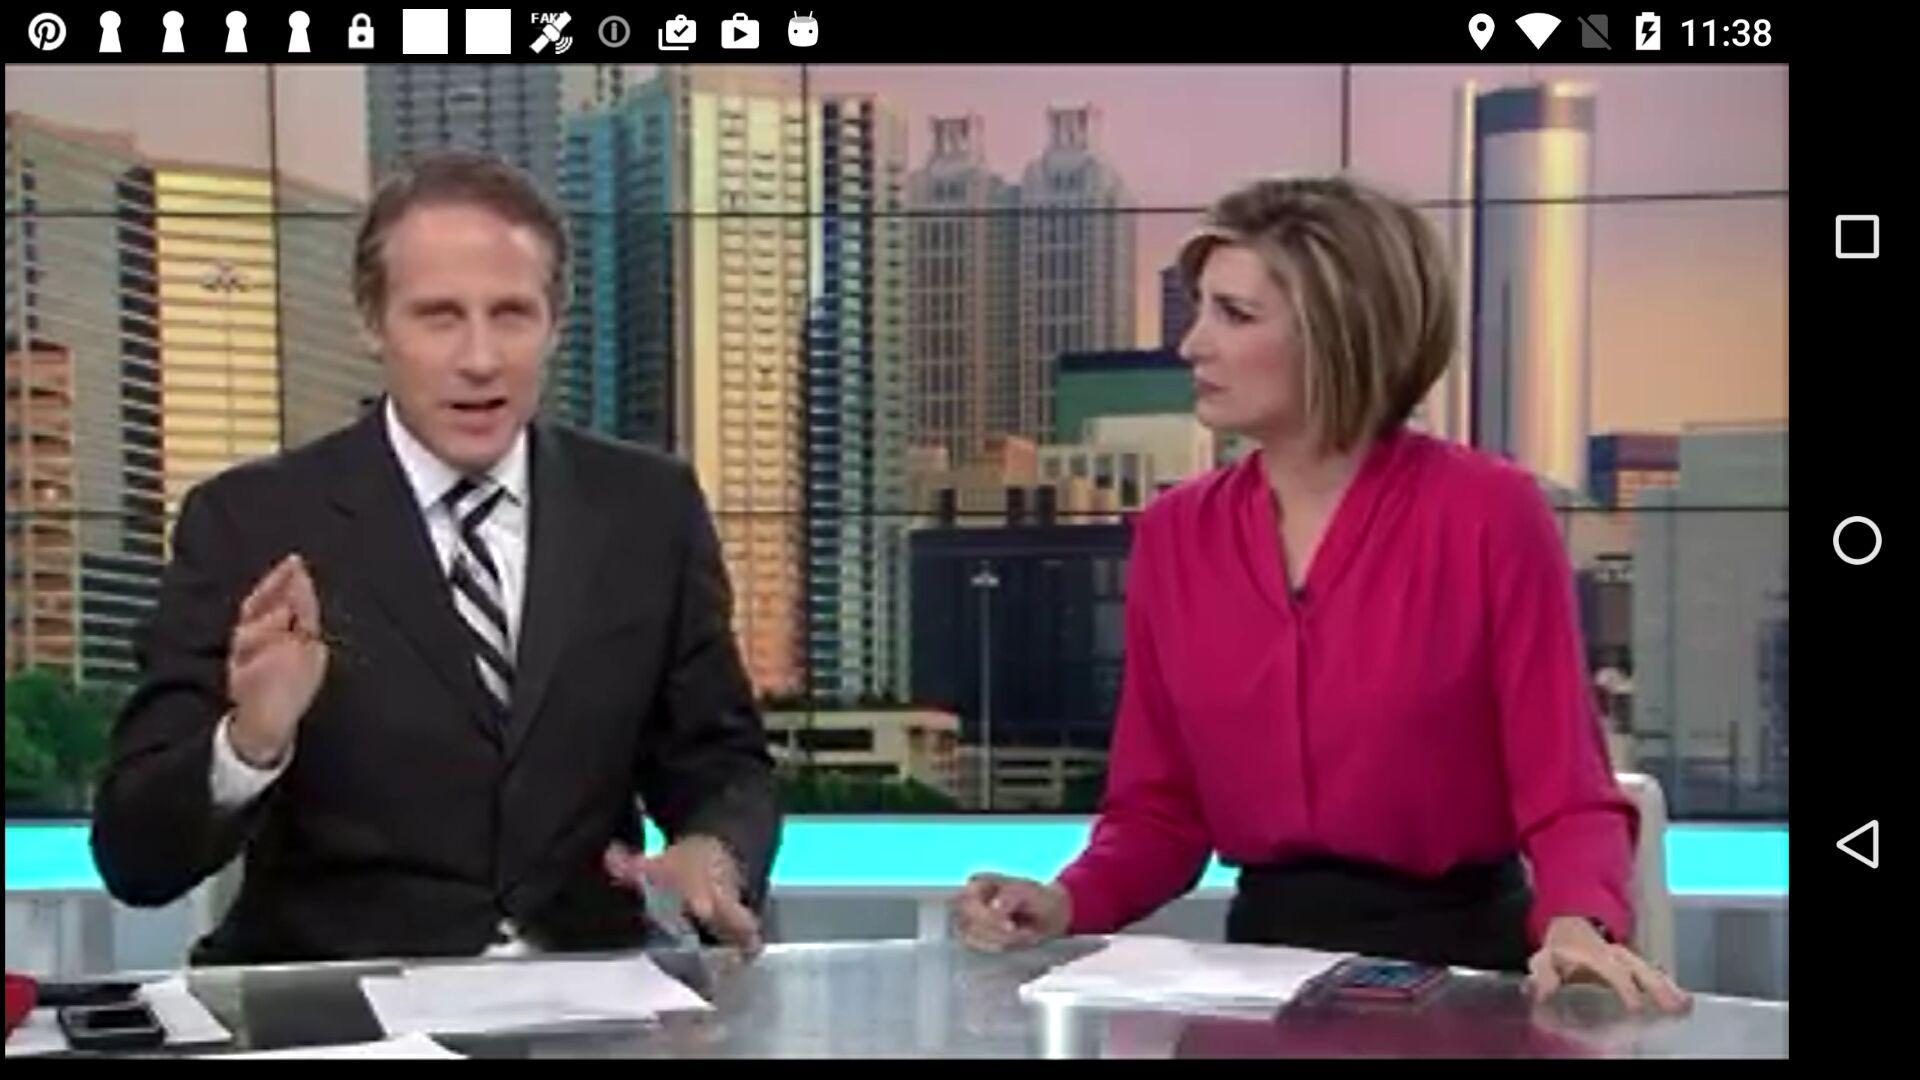How many notifications are pending? There are more than 9 notifications pending. 